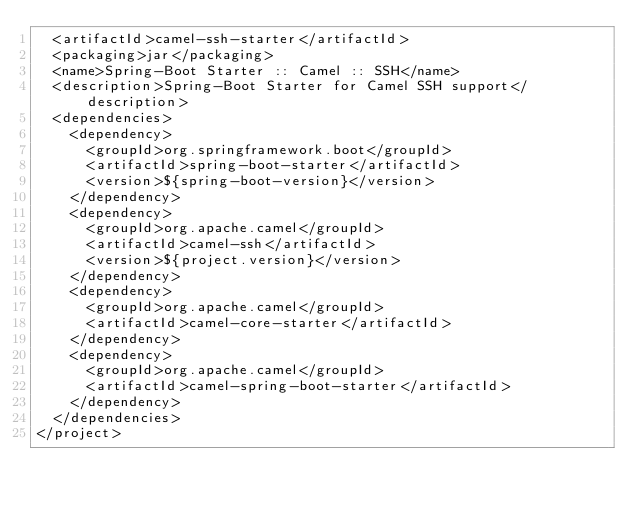<code> <loc_0><loc_0><loc_500><loc_500><_XML_>  <artifactId>camel-ssh-starter</artifactId>
  <packaging>jar</packaging>
  <name>Spring-Boot Starter :: Camel :: SSH</name>
  <description>Spring-Boot Starter for Camel SSH support</description>
  <dependencies>
    <dependency>
      <groupId>org.springframework.boot</groupId>
      <artifactId>spring-boot-starter</artifactId>
      <version>${spring-boot-version}</version>
    </dependency>
    <dependency>
      <groupId>org.apache.camel</groupId>
      <artifactId>camel-ssh</artifactId>
      <version>${project.version}</version>
    </dependency>
    <dependency>
      <groupId>org.apache.camel</groupId>
      <artifactId>camel-core-starter</artifactId>
    </dependency>
    <dependency>
      <groupId>org.apache.camel</groupId>
      <artifactId>camel-spring-boot-starter</artifactId>
    </dependency>
  </dependencies>
</project>
</code> 